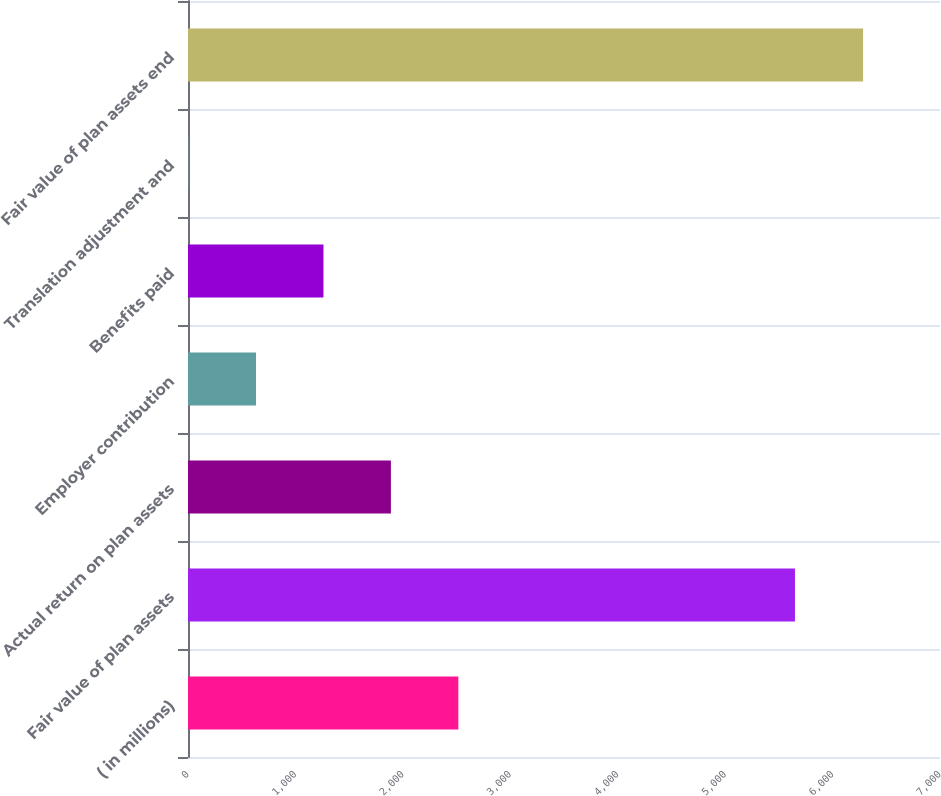<chart> <loc_0><loc_0><loc_500><loc_500><bar_chart><fcel>( in millions)<fcel>Fair value of plan assets<fcel>Actual return on plan assets<fcel>Employer contribution<fcel>Benefits paid<fcel>Translation adjustment and<fcel>Fair value of plan assets end<nl><fcel>2516.6<fcel>5650<fcel>1888.7<fcel>632.9<fcel>1260.8<fcel>5<fcel>6284<nl></chart> 